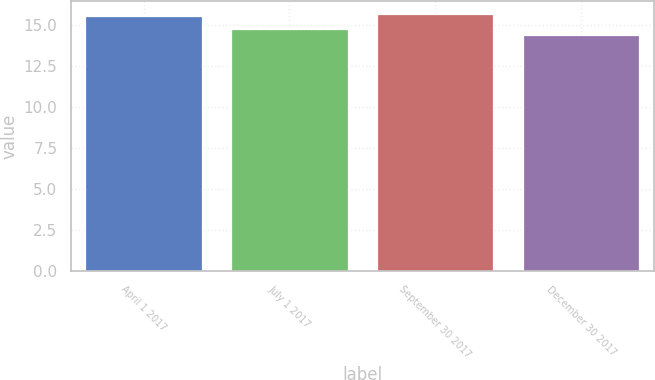<chart> <loc_0><loc_0><loc_500><loc_500><bar_chart><fcel>April 1 2017<fcel>July 1 2017<fcel>September 30 2017<fcel>December 30 2017<nl><fcel>15.55<fcel>14.74<fcel>15.67<fcel>14.41<nl></chart> 